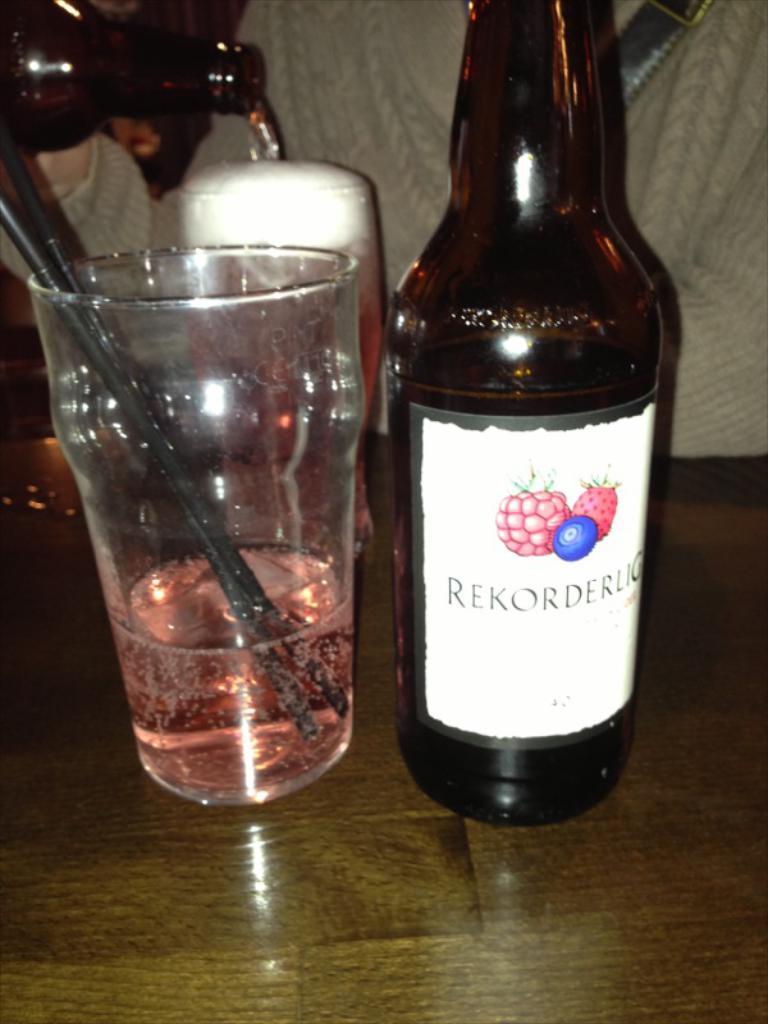What is the brand of wine?
Provide a succinct answer. Rekorderlig. 